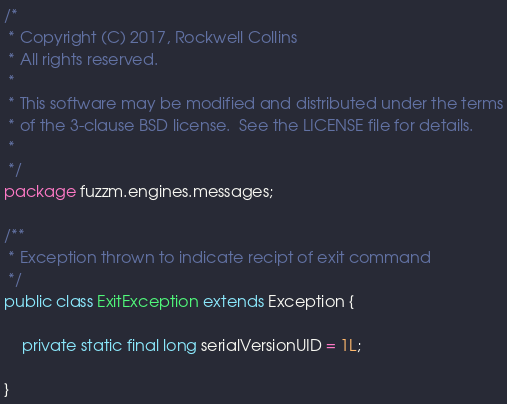Convert code to text. <code><loc_0><loc_0><loc_500><loc_500><_Java_>/* 
 * Copyright (C) 2017, Rockwell Collins
 * All rights reserved.
 *
 * This software may be modified and distributed under the terms
 * of the 3-clause BSD license.  See the LICENSE file for details.
 * 
 */
package fuzzm.engines.messages;

/**
 * Exception thrown to indicate recipt of exit command
 */
public class ExitException extends Exception {

	private static final long serialVersionUID = 1L;

}
</code> 